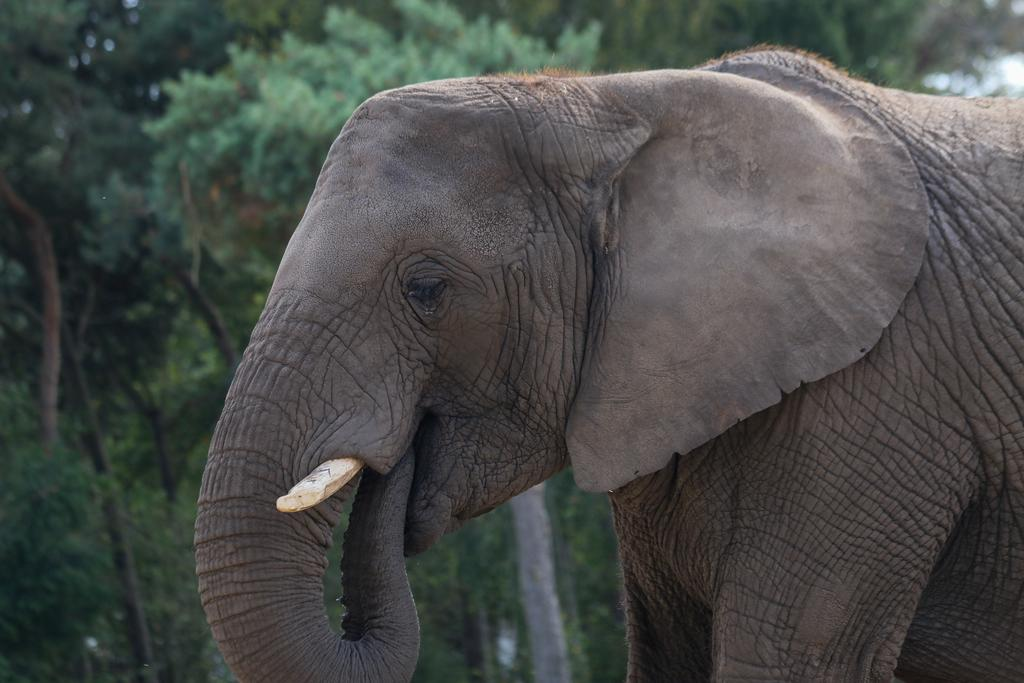What animal is present in the image? There is an elephant in the image. What can be seen in the background of the image? There are trees in the background of the image. How would you describe the overall quality of the image? The image is slightly blurry in the background. What type of wound can be seen on the elephant's face in the image? There is no wound visible on the elephant's face in the image. How many bubbles are surrounding the elephant in the image? There are no bubbles present in the image. 